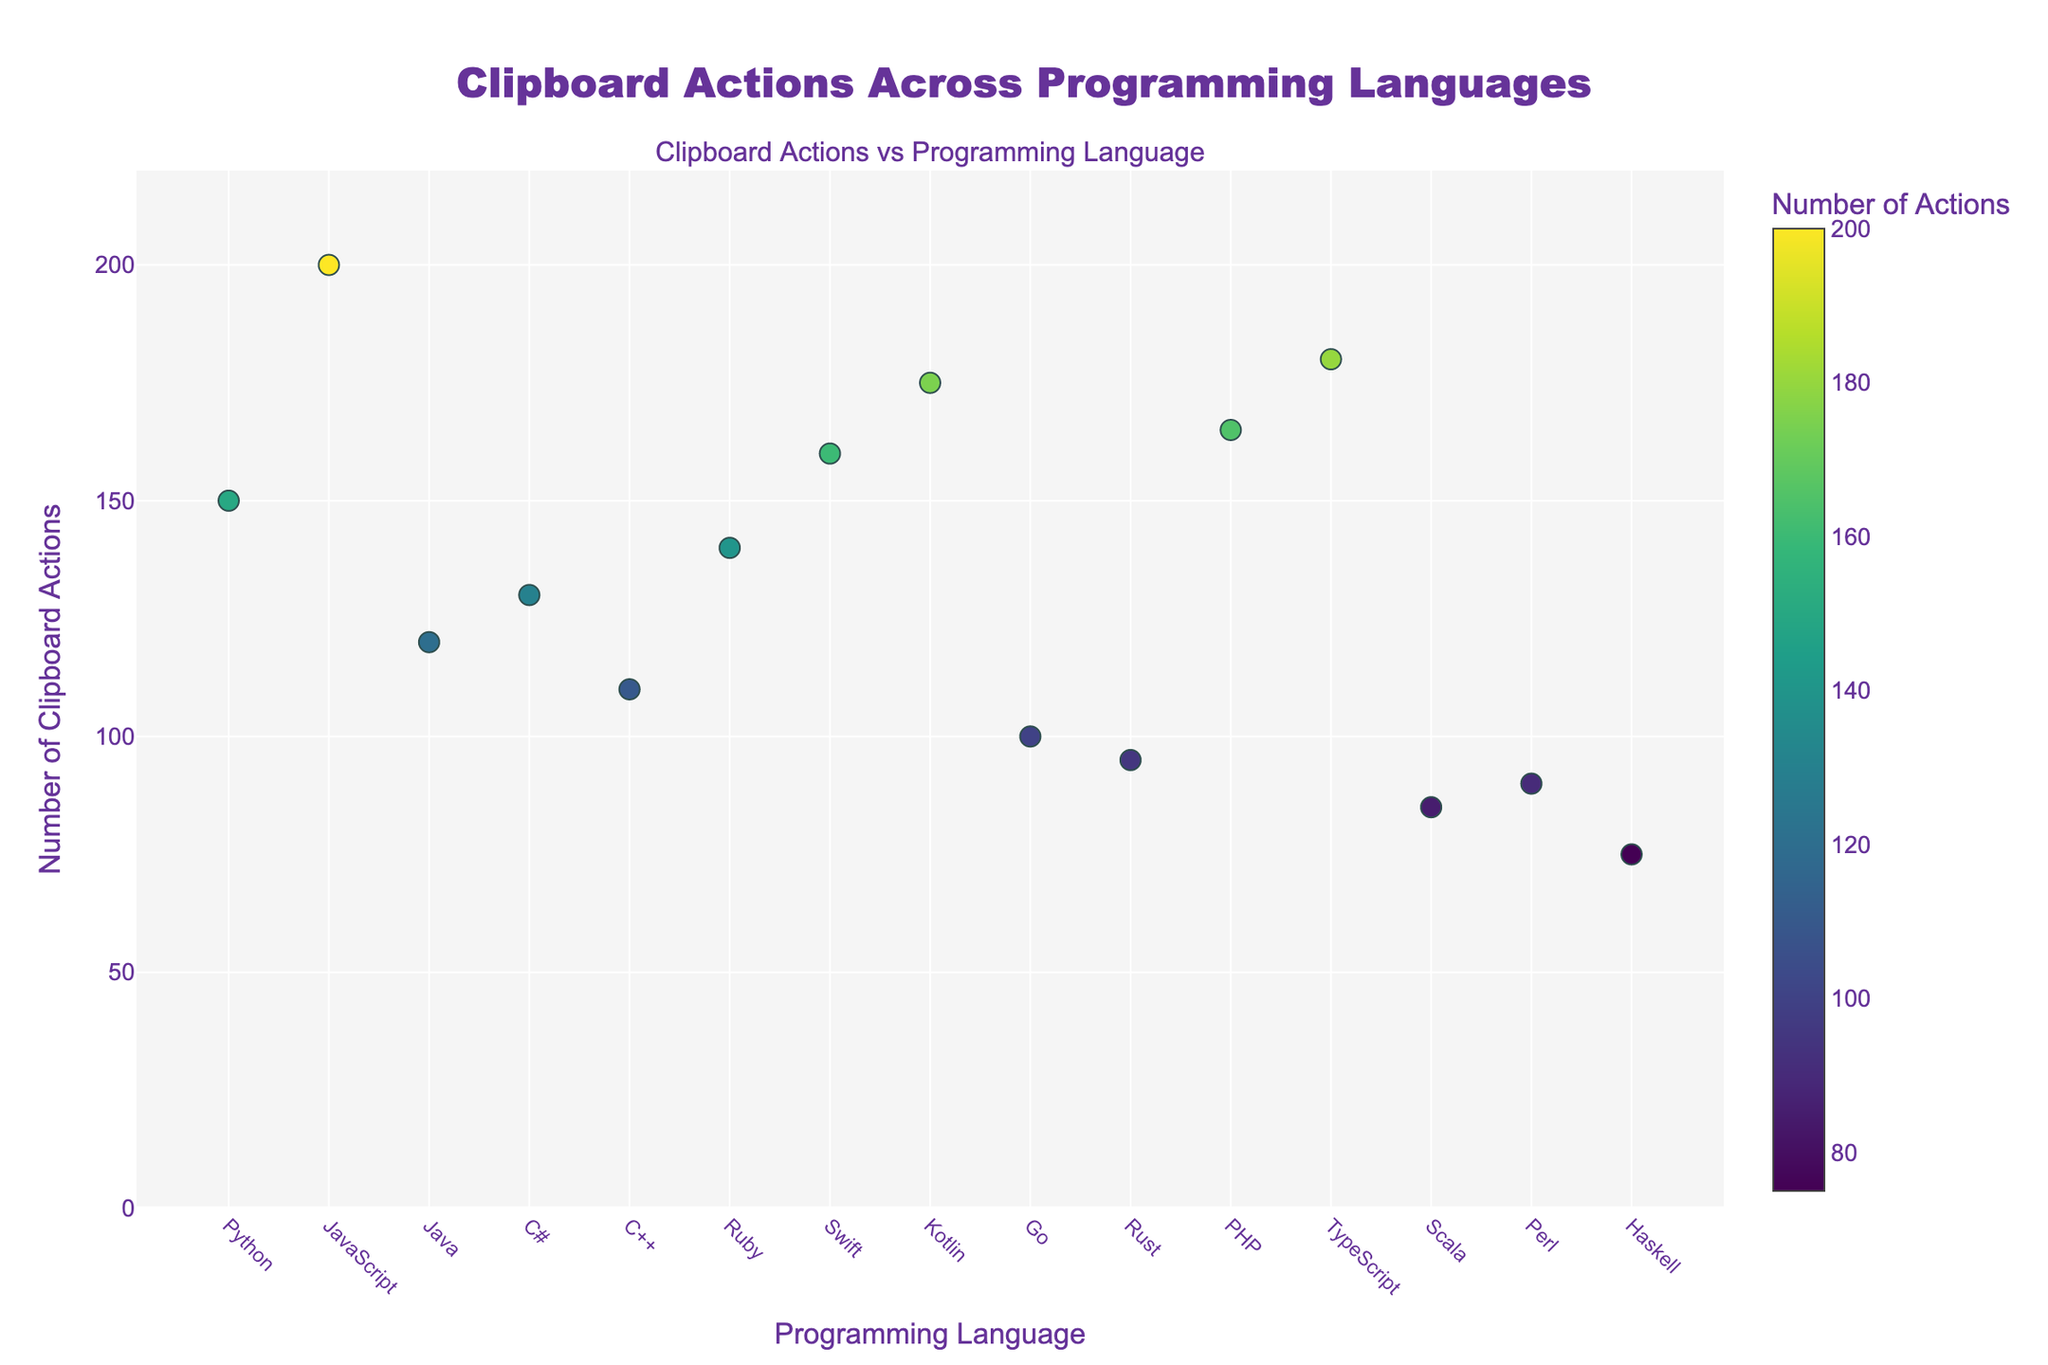How many programming languages are shown in the scatter plot? Count the unique programming languages displayed along the x-axis.
Answer: 15 Which programming language has the highest number of clipboard actions? Look for the data point with the highest value on the y-axis and check the corresponding label on the x-axis.
Answer: JavaScript Which programming language has the lowest number of clipboard actions? Identify the data point with the lowest value on the y-axis and check the corresponding label on the x-axis.
Answer: Haskell What is the range of clipboard actions across the programming languages? Subtract the smallest number of clipboard actions (75 for Haskell) from the largest number of clipboard actions (200 for JavaScript).
Answer: 125 What is the average number of clipboard actions performed for the displayed programming languages? Sum all the clipboard action values and divide by the number of programming languages (15). (150+200+120+130+110+140+160+175+100+95+165+180+85+90+75) = 1975, so the average is 1975/15 = 131.67
Answer: 131.67 Which programming languages have a number of clipboard actions greater than 150? Identify data points with values higher than 150 on the y-axis and look at their corresponding labels on the x-axis.
Answer: Python, JavaScript, Swift, Kotlin, PHP, TypeScript Which programming language has a number of clipboard actions closest to the median value? First, sort the values and find the median. The median in 15 values is the 8th data point. Ordered values: (75, 85, 90, 95, 100, 110, 120, 130, 140, 150, 160, 165, 175, 180, 200). The 8th value is 130. Find the corresponding programming language.
Answer: C# Which two programming languages have clipboard actions differing by exactly 10? Look for pairs of data points where the difference between the y-values is exactly 10.
Answer: Rust and Perl (95 and 85), Java and C# (120 and 130) What is the total number of clipboard actions for Python, Ruby, and Scala combined? Sum the clipboard actions for Python, Ruby, and Scala. (150 + 140 + 85) = 375
Answer: 375 Is there any programming language with exactly 110 clipboard actions? Check if any data point has a y-value of 110 and identify the corresponding programming language.
Answer: C++ 